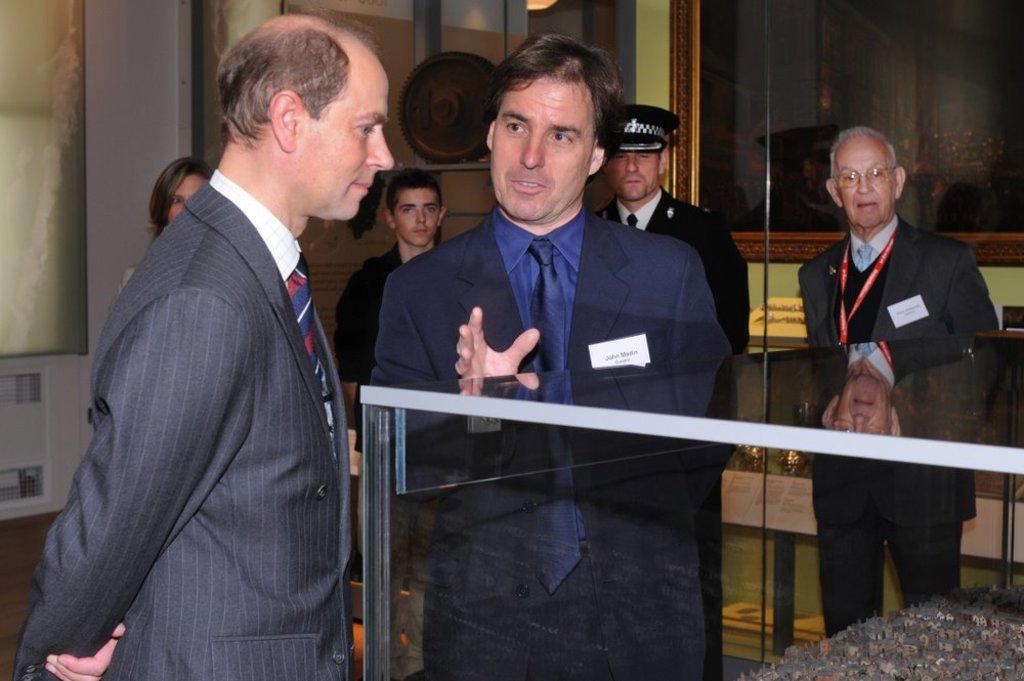What is the main focus of the image? The main focus of the image is the many persons standing in the center. What can be seen beneath the persons in the image? There is a floor visible in the image. Are there any other people visible in the image besides those in the center? Yes, there are persons in the background of the image. What objects can be seen in the background of the image? There is a photo frame and a wall in the background of the image. What type of foot is used to support the persons standing in the image? There is no specific type of foot mentioned or visible in the image; the persons are standing on a floor. 